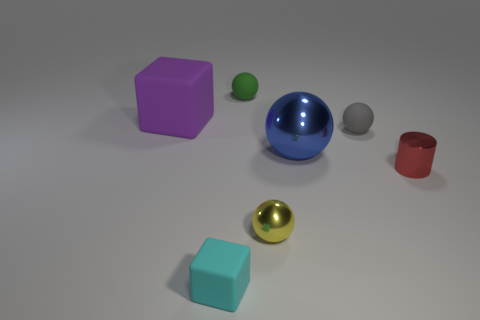Subtract 1 balls. How many balls are left? 3 Add 2 big blue objects. How many objects exist? 9 Subtract all spheres. How many objects are left? 3 Subtract 0 yellow cubes. How many objects are left? 7 Subtract all small green balls. Subtract all large blue metal spheres. How many objects are left? 5 Add 4 small rubber objects. How many small rubber objects are left? 7 Add 1 small green things. How many small green things exist? 2 